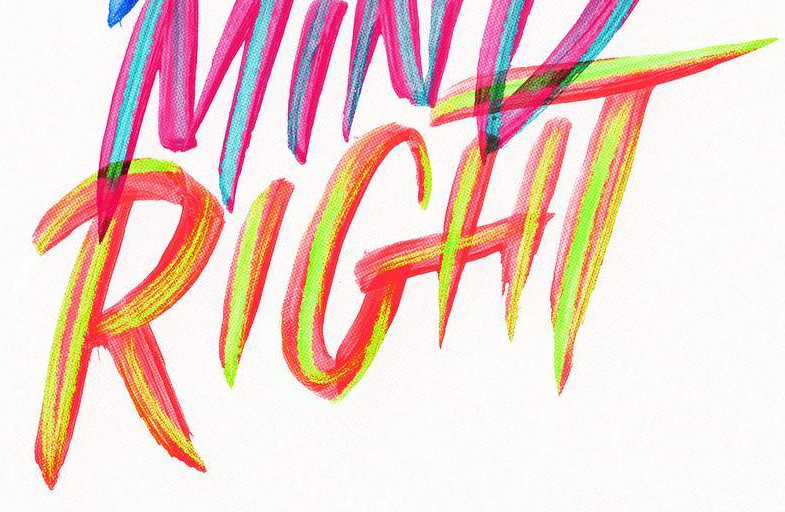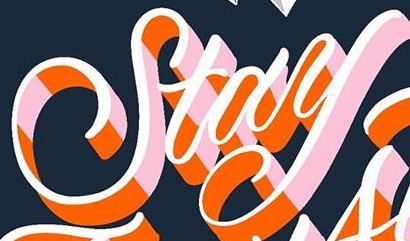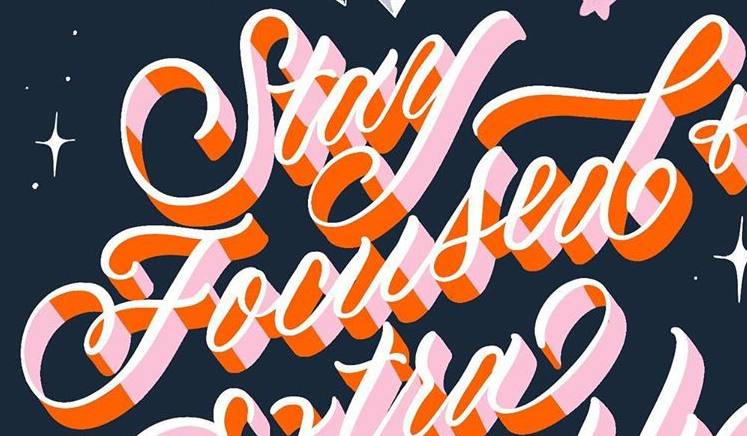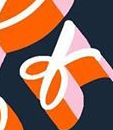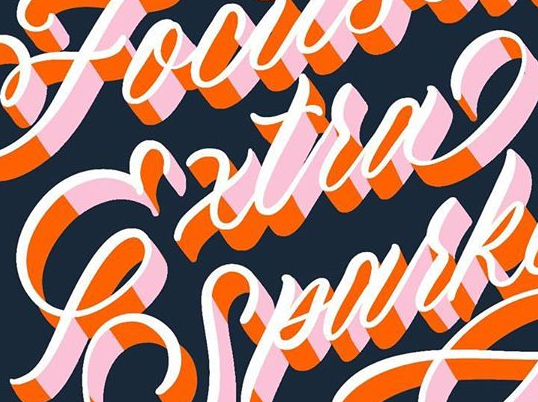Identify the words shown in these images in order, separated by a semicolon. RIGHT; Stay; Focused; of; Extra 